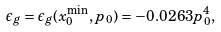<formula> <loc_0><loc_0><loc_500><loc_500>\epsilon _ { g } = \epsilon _ { g } ( x _ { 0 } ^ { \min } , p _ { 0 } ) = - 0 . 0 2 6 3 p _ { 0 } ^ { 4 } ,</formula> 